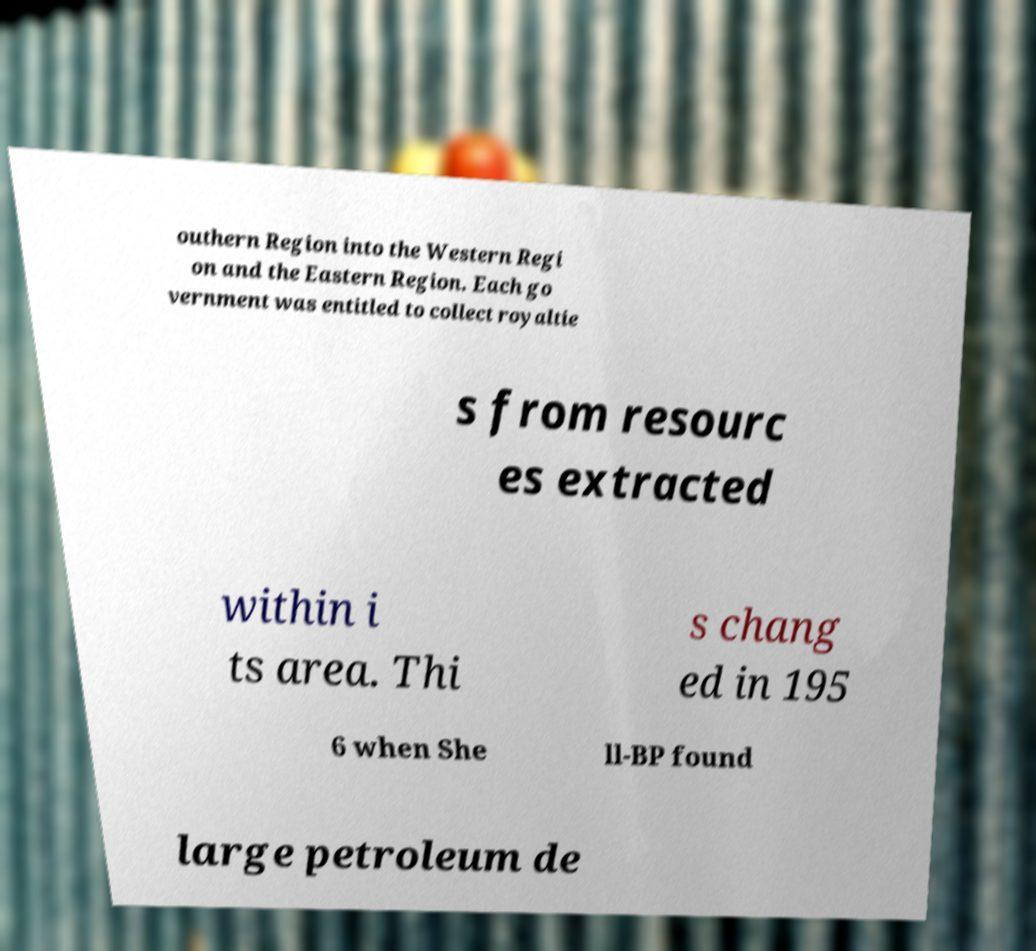What messages or text are displayed in this image? I need them in a readable, typed format. outhern Region into the Western Regi on and the Eastern Region. Each go vernment was entitled to collect royaltie s from resourc es extracted within i ts area. Thi s chang ed in 195 6 when She ll-BP found large petroleum de 